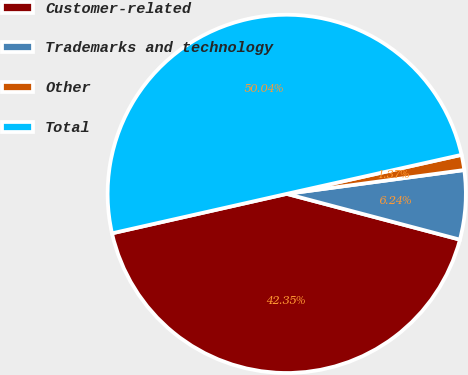<chart> <loc_0><loc_0><loc_500><loc_500><pie_chart><fcel>Customer-related<fcel>Trademarks and technology<fcel>Other<fcel>Total<nl><fcel>42.35%<fcel>6.24%<fcel>1.37%<fcel>50.04%<nl></chart> 